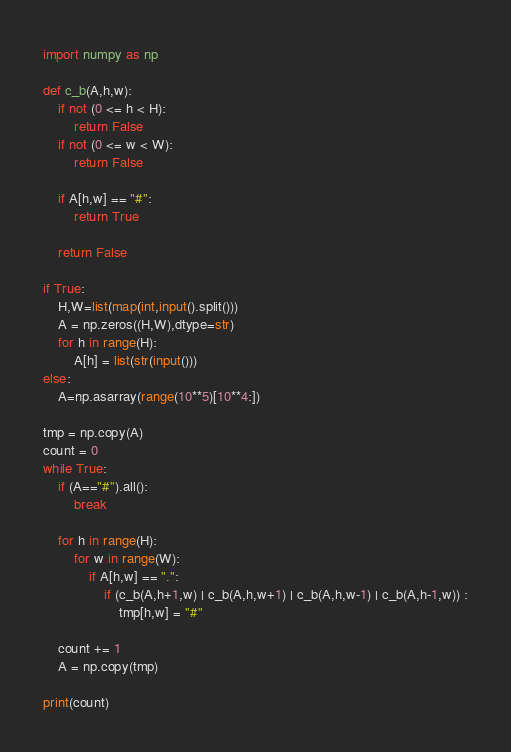<code> <loc_0><loc_0><loc_500><loc_500><_Python_>import numpy as np

def c_b(A,h,w):
    if not (0 <= h < H):
        return False
    if not (0 <= w < W):
        return False

    if A[h,w] == "#":
        return True

    return False

if True:
    H,W=list(map(int,input().split()))
    A = np.zeros((H,W),dtype=str)
    for h in range(H):
        A[h] = list(str(input()))
else:
    A=np.asarray(range(10**5)[10**4:])

tmp = np.copy(A)
count = 0
while True:
    if (A=="#").all():
        break

    for h in range(H):
        for w in range(W):
            if A[h,w] == ".":
                if (c_b(A,h+1,w) | c_b(A,h,w+1) | c_b(A,h,w-1) | c_b(A,h-1,w)) :
                    tmp[h,w] = "#"

    count += 1
    A = np.copy(tmp)

print(count)
</code> 